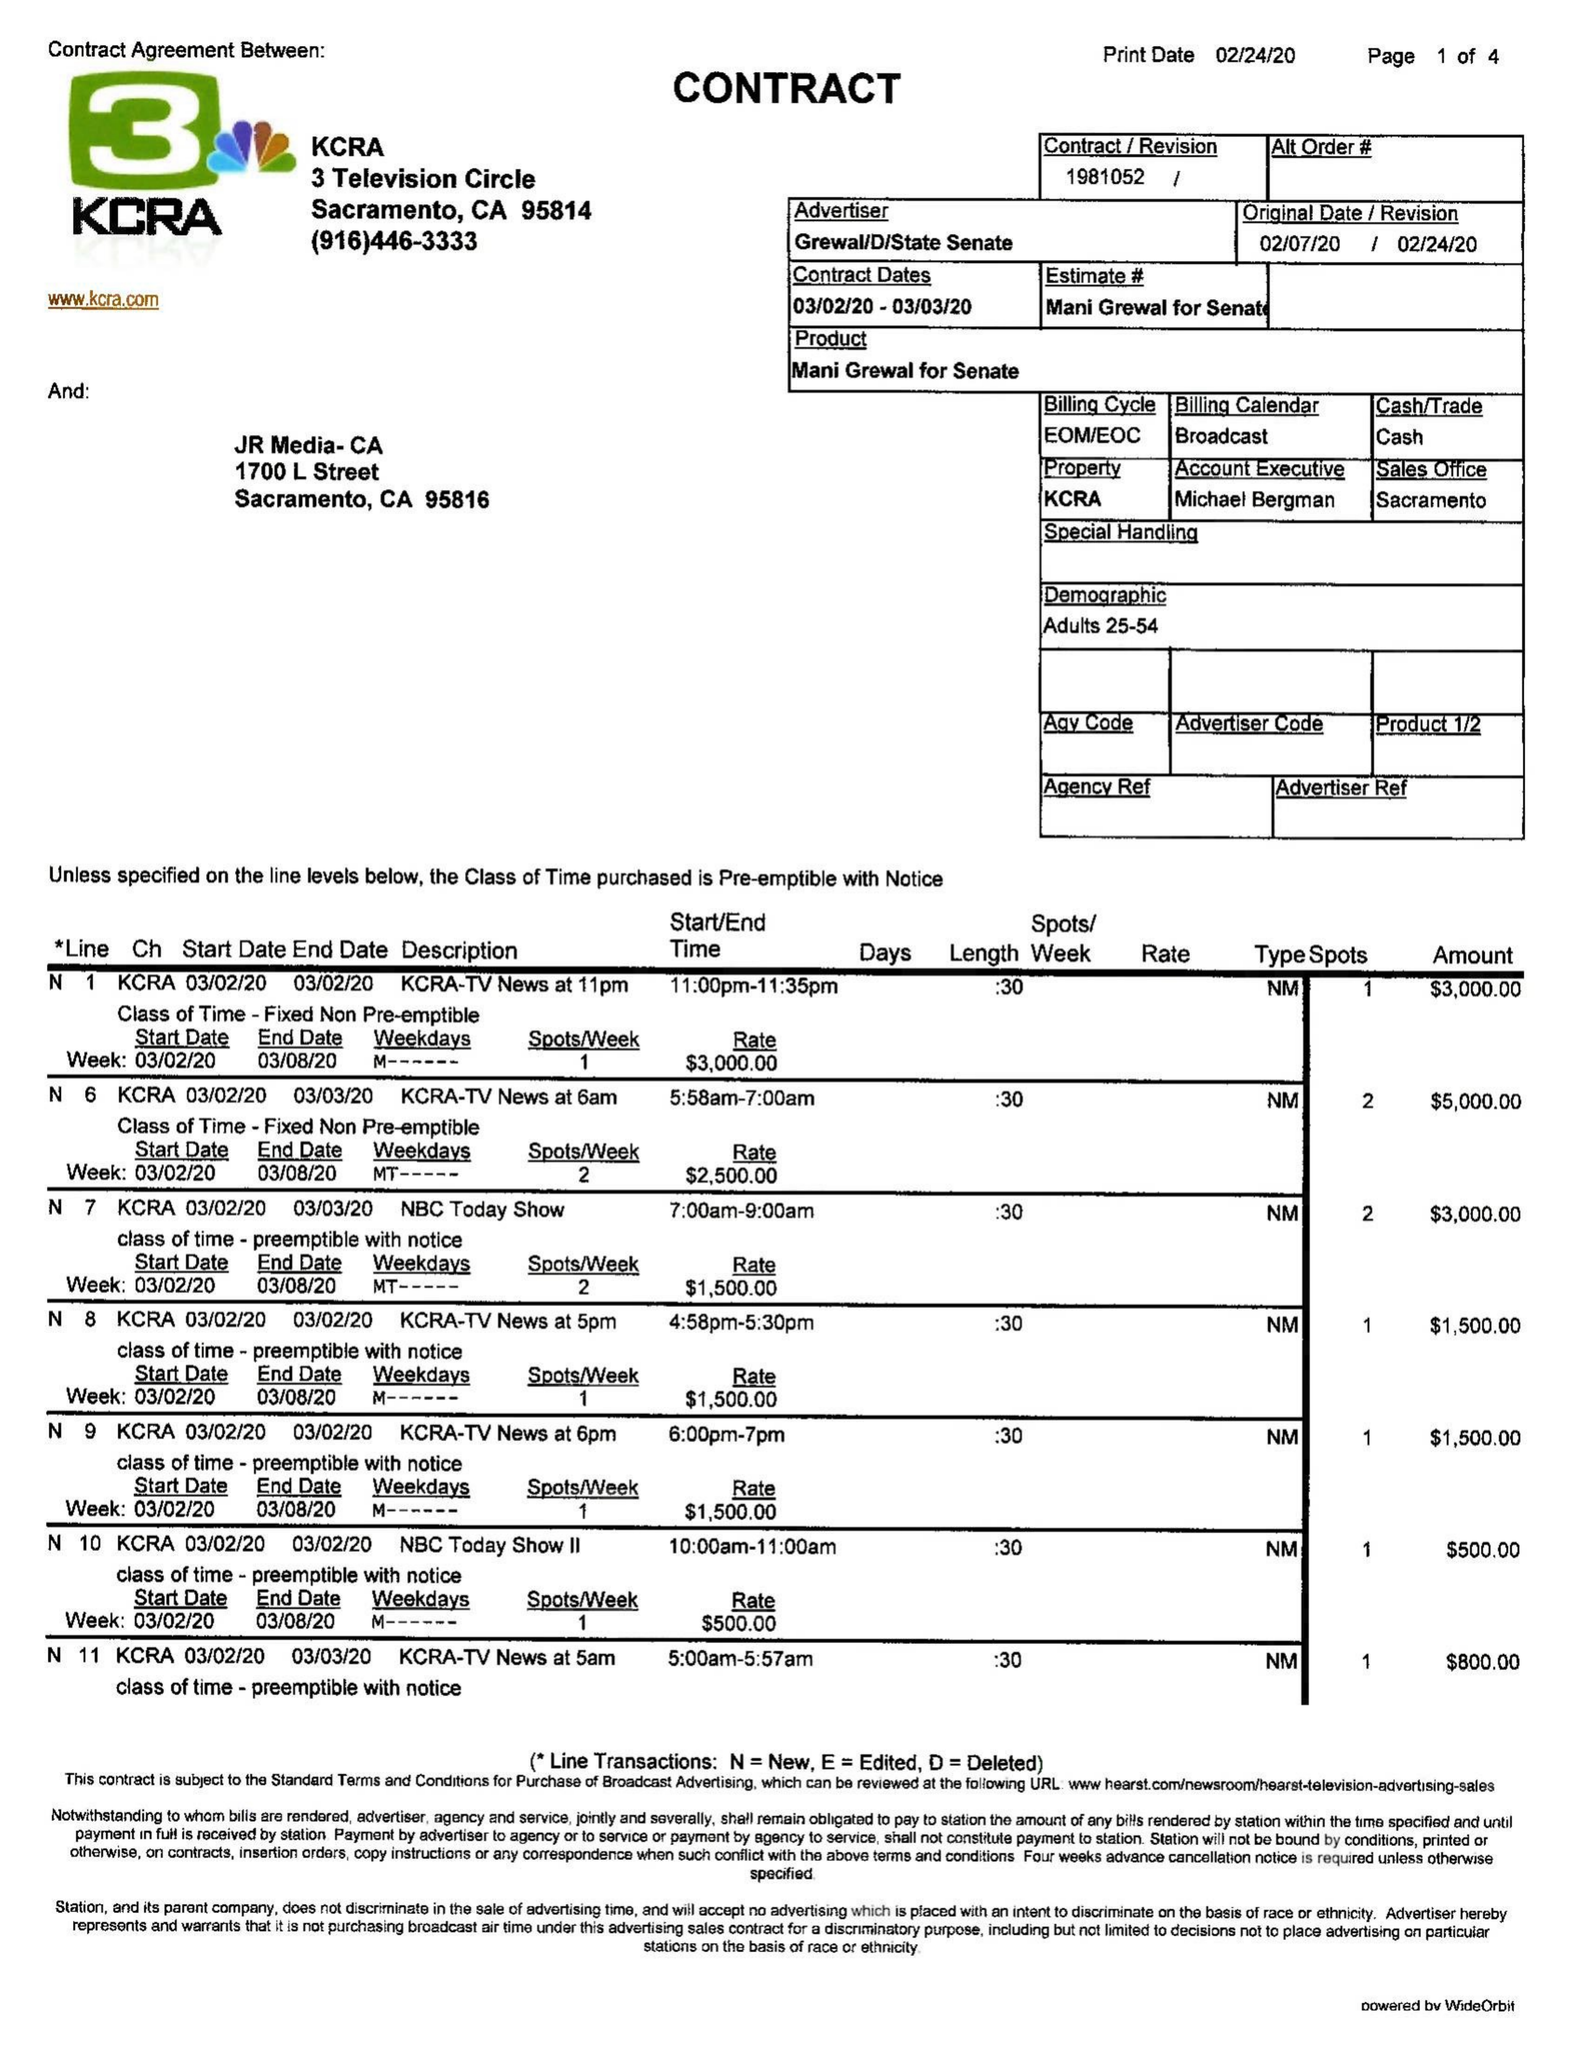What is the value for the advertiser?
Answer the question using a single word or phrase. GREWAL/D/STATESENATE 